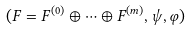Convert formula to latex. <formula><loc_0><loc_0><loc_500><loc_500>( F = F ^ { ( 0 ) } \oplus \dots \oplus F ^ { ( m ) } , \psi , \varphi )</formula> 